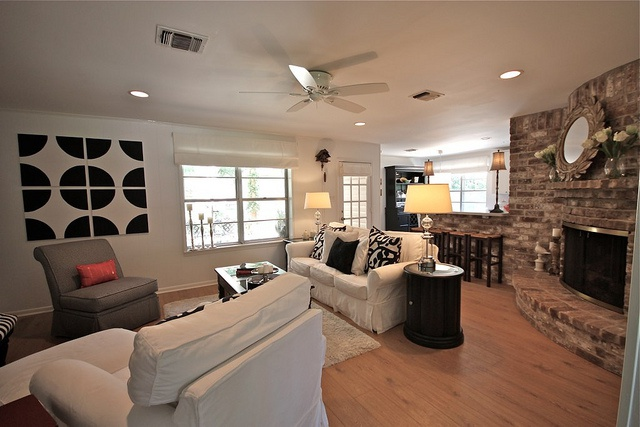Describe the objects in this image and their specific colors. I can see couch in gray and darkgray tones, couch in gray, black, and tan tones, chair in gray, black, and maroon tones, vase in gray, maroon, and black tones, and clock in gray, black, maroon, and brown tones in this image. 